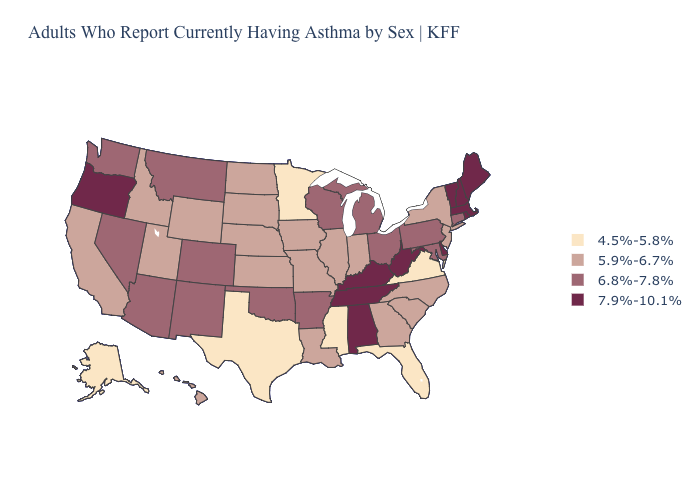How many symbols are there in the legend?
Be succinct. 4. What is the value of Minnesota?
Quick response, please. 4.5%-5.8%. What is the value of Montana?
Be succinct. 6.8%-7.8%. Does New York have the highest value in the USA?
Keep it brief. No. Among the states that border Montana , which have the lowest value?
Be succinct. Idaho, North Dakota, South Dakota, Wyoming. Does New Hampshire have a higher value than Kentucky?
Quick response, please. No. What is the highest value in the South ?
Answer briefly. 7.9%-10.1%. Does New Hampshire have a higher value than New Mexico?
Write a very short answer. Yes. Which states have the lowest value in the USA?
Keep it brief. Alaska, Florida, Minnesota, Mississippi, Texas, Virginia. What is the value of Vermont?
Keep it brief. 7.9%-10.1%. Name the states that have a value in the range 4.5%-5.8%?
Keep it brief. Alaska, Florida, Minnesota, Mississippi, Texas, Virginia. What is the value of Iowa?
Concise answer only. 5.9%-6.7%. Which states have the lowest value in the Northeast?
Concise answer only. New Jersey, New York. How many symbols are there in the legend?
Give a very brief answer. 4. Does the map have missing data?
Concise answer only. No. 